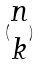<formula> <loc_0><loc_0><loc_500><loc_500>( \begin{matrix} n \\ k \end{matrix} )</formula> 